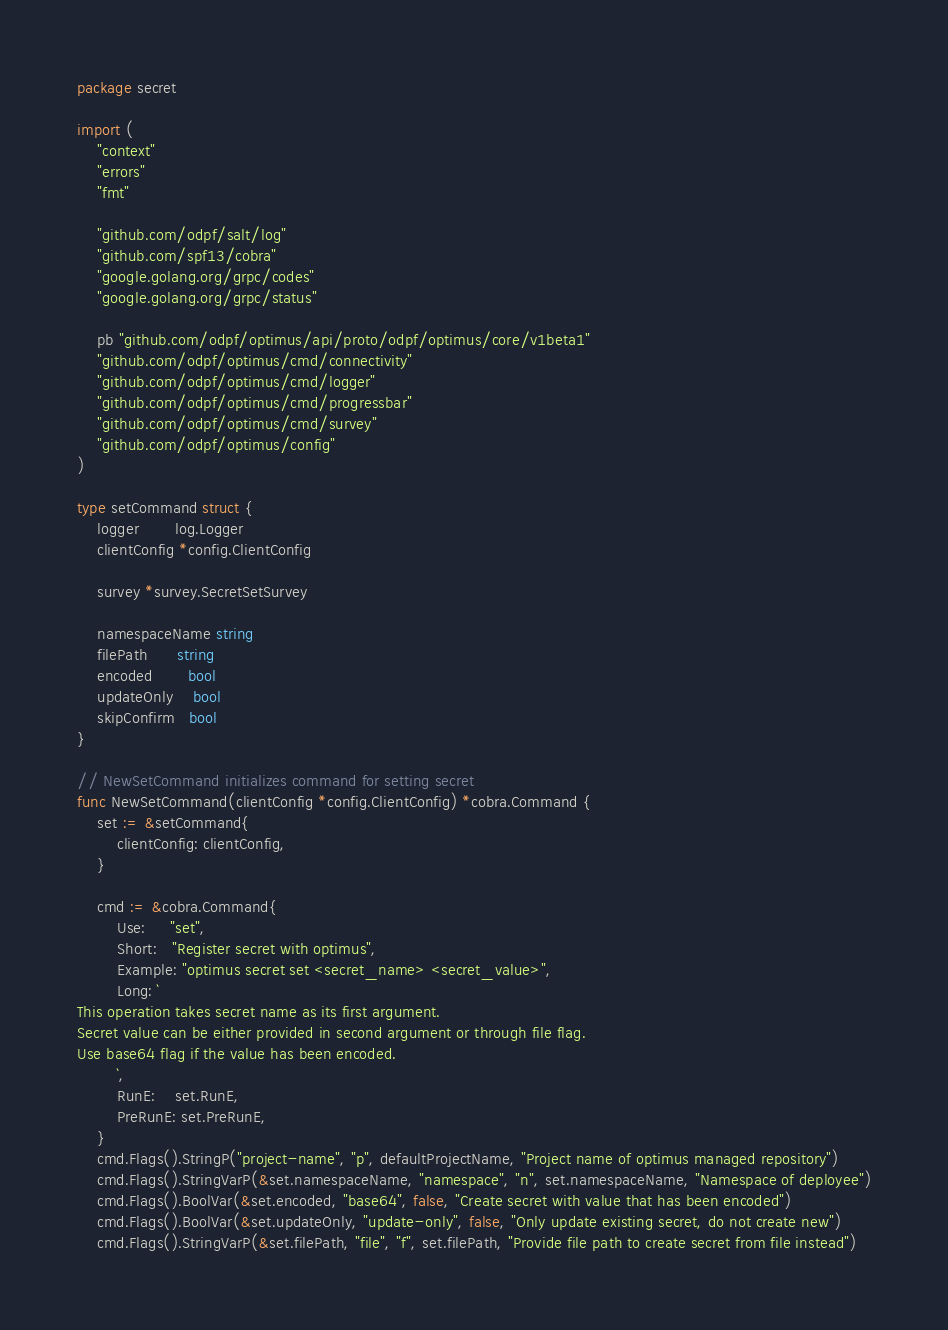Convert code to text. <code><loc_0><loc_0><loc_500><loc_500><_Go_>package secret

import (
	"context"
	"errors"
	"fmt"

	"github.com/odpf/salt/log"
	"github.com/spf13/cobra"
	"google.golang.org/grpc/codes"
	"google.golang.org/grpc/status"

	pb "github.com/odpf/optimus/api/proto/odpf/optimus/core/v1beta1"
	"github.com/odpf/optimus/cmd/connectivity"
	"github.com/odpf/optimus/cmd/logger"
	"github.com/odpf/optimus/cmd/progressbar"
	"github.com/odpf/optimus/cmd/survey"
	"github.com/odpf/optimus/config"
)

type setCommand struct {
	logger       log.Logger
	clientConfig *config.ClientConfig

	survey *survey.SecretSetSurvey

	namespaceName string
	filePath      string
	encoded       bool
	updateOnly    bool
	skipConfirm   bool
}

// NewSetCommand initializes command for setting secret
func NewSetCommand(clientConfig *config.ClientConfig) *cobra.Command {
	set := &setCommand{
		clientConfig: clientConfig,
	}

	cmd := &cobra.Command{
		Use:     "set",
		Short:   "Register secret with optimus",
		Example: "optimus secret set <secret_name> <secret_value>",
		Long: `
This operation takes secret name as its first argument. 
Secret value can be either provided in second argument or through file flag. 
Use base64 flag if the value has been encoded.
		`,
		RunE:    set.RunE,
		PreRunE: set.PreRunE,
	}
	cmd.Flags().StringP("project-name", "p", defaultProjectName, "Project name of optimus managed repository")
	cmd.Flags().StringVarP(&set.namespaceName, "namespace", "n", set.namespaceName, "Namespace of deployee")
	cmd.Flags().BoolVar(&set.encoded, "base64", false, "Create secret with value that has been encoded")
	cmd.Flags().BoolVar(&set.updateOnly, "update-only", false, "Only update existing secret, do not create new")
	cmd.Flags().StringVarP(&set.filePath, "file", "f", set.filePath, "Provide file path to create secret from file instead")</code> 